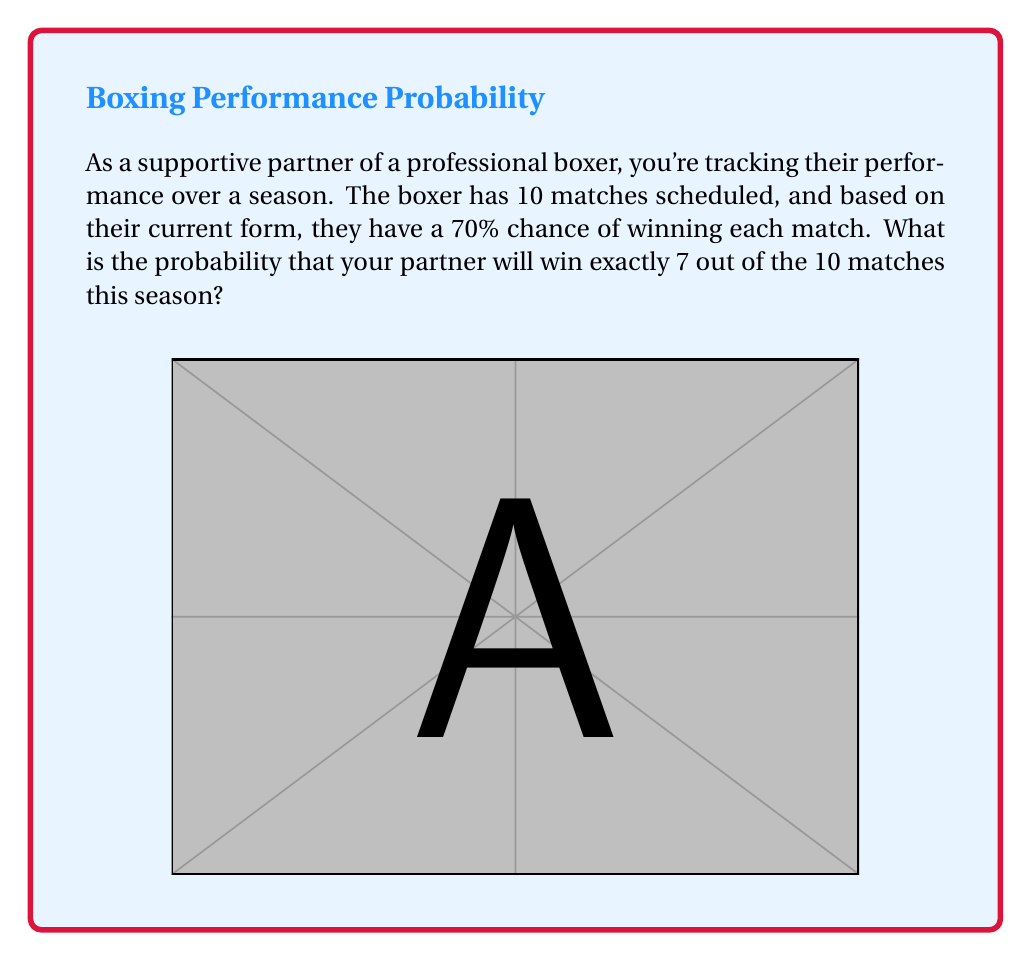Can you solve this math problem? To solve this problem, we'll use the binomial probability formula:

$$P(X = k) = \binom{n}{k} p^k (1-p)^{n-k}$$

Where:
- $n$ is the number of trials (matches)
- $k$ is the number of successes (wins)
- $p$ is the probability of success on each trial

Given:
- $n = 10$ (total matches)
- $k = 7$ (desired number of wins)
- $p = 0.7$ (probability of winning each match)

Step 1: Calculate the binomial coefficient $\binom{10}{7}$
$$\binom{10}{7} = \frac{10!}{7!(10-7)!} = \frac{10!}{7!3!} = 120$$

Step 2: Calculate $p^k$ and $(1-p)^{n-k}$
$$p^k = 0.7^7 \approx 0.0824$$
$$(1-p)^{n-k} = 0.3^3 \approx 0.027$$

Step 3: Apply the binomial probability formula
$$P(X = 7) = 120 \times 0.0824 \times 0.027 \approx 0.2668$$

Therefore, the probability of your partner winning exactly 7 out of 10 matches is approximately 0.2668 or 26.68%.
Answer: $0.2668$ or $26.68\%$ 